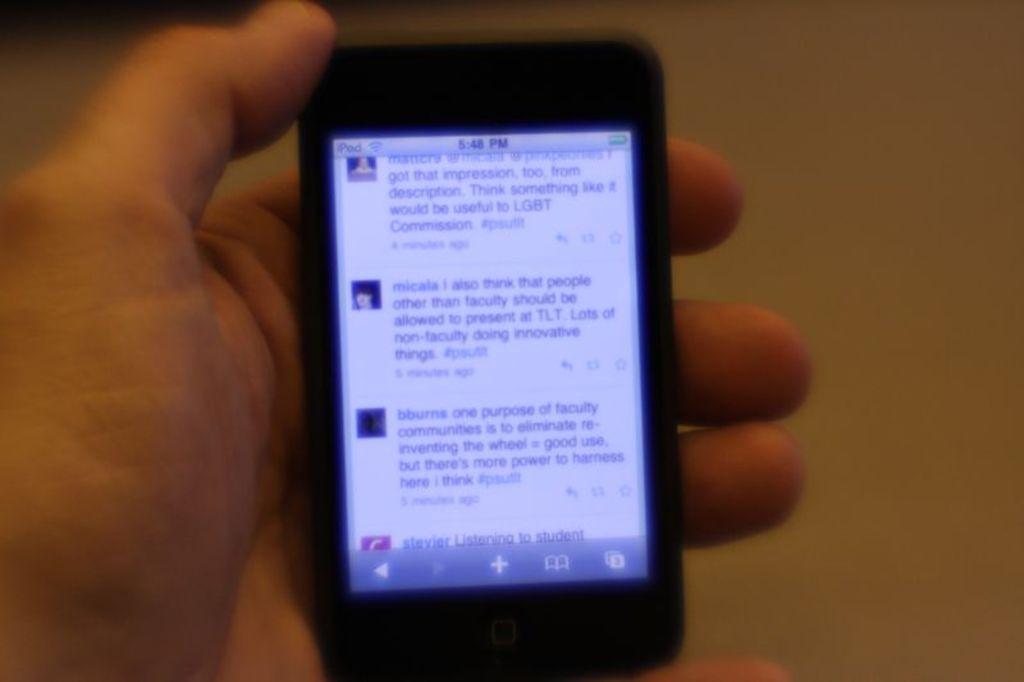In one or two sentences, can you explain what this image depicts? In this picture there is a person's hand holding a mobile. The background is blurred. 